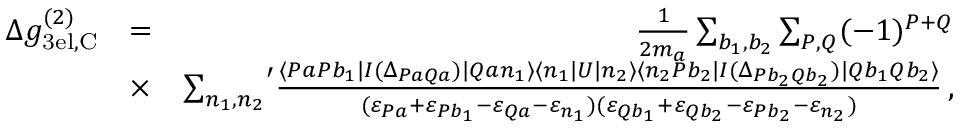Convert formula to latex. <formula><loc_0><loc_0><loc_500><loc_500>\begin{array} { r l r } { \Delta g _ { 3 e l , C } ^ { ( 2 ) } } & { = } & { \frac { 1 } { 2 m _ { a } } \sum _ { b _ { 1 } , b _ { 2 } } \sum _ { P , Q } ( - 1 ) ^ { P + Q } } \\ & { \times } & { { \sum _ { n _ { 1 } , n _ { 2 } } } ^ { \prime } \frac { \langle P a P b _ { 1 } | I ( \Delta _ { P a Q a } ) | Q a n _ { 1 } \rangle \langle n _ { 1 } | U | n _ { 2 } \rangle \langle n _ { 2 } P b _ { 2 } | I ( \Delta _ { P b _ { 2 } Q b _ { 2 } } ) | Q b _ { 1 } Q b _ { 2 } \rangle } { ( \varepsilon _ { P a } + \varepsilon _ { P b _ { 1 } } - \varepsilon _ { Q a } - \varepsilon _ { n _ { 1 } } ) ( \varepsilon _ { Q b _ { 1 } } + \varepsilon _ { Q b _ { 2 } } - \varepsilon _ { P b _ { 2 } } - \varepsilon _ { n _ { 2 } } ) } \, , } \end{array}</formula> 